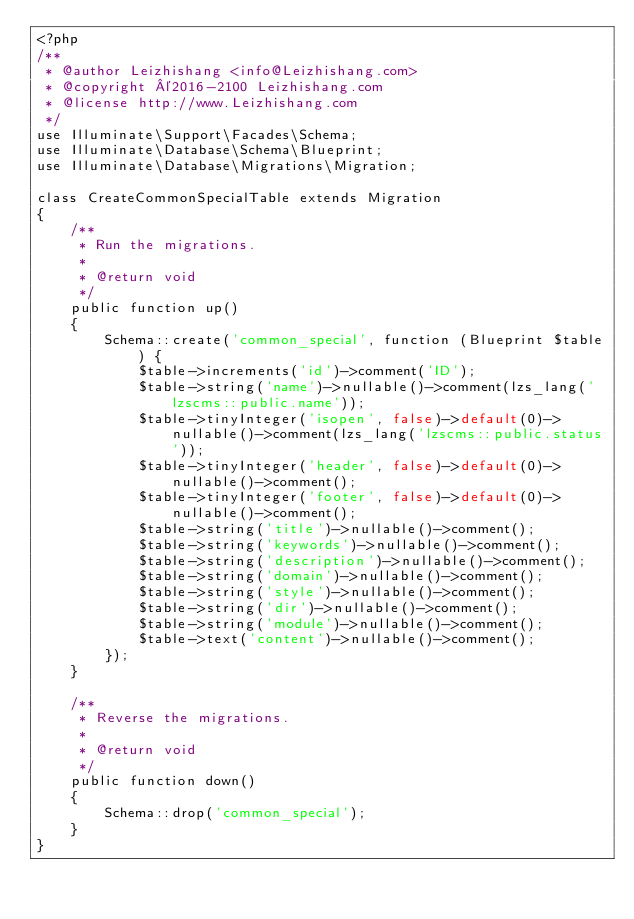<code> <loc_0><loc_0><loc_500><loc_500><_PHP_><?php
/**
 * @author Leizhishang <info@Leizhishang.com>
 * @copyright ©2016-2100 Leizhishang.com
 * @license http://www.Leizhishang.com
 */
use Illuminate\Support\Facades\Schema;
use Illuminate\Database\Schema\Blueprint;
use Illuminate\Database\Migrations\Migration;

class CreateCommonSpecialTable extends Migration
{
    /**
     * Run the migrations.
     *
     * @return void
     */
    public function up()
    {
        Schema::create('common_special', function (Blueprint $table) {
            $table->increments('id')->comment('ID');
            $table->string('name')->nullable()->comment(lzs_lang('lzscms::public.name'));
            $table->tinyInteger('isopen', false)->default(0)->nullable()->comment(lzs_lang('lzscms::public.status'));
            $table->tinyInteger('header', false)->default(0)->nullable()->comment();
            $table->tinyInteger('footer', false)->default(0)->nullable()->comment();
            $table->string('title')->nullable()->comment();
            $table->string('keywords')->nullable()->comment();
            $table->string('description')->nullable()->comment();
            $table->string('domain')->nullable()->comment();
            $table->string('style')->nullable()->comment();
            $table->string('dir')->nullable()->comment();
            $table->string('module')->nullable()->comment();
            $table->text('content')->nullable()->comment();
        });
    }

    /**
     * Reverse the migrations.
     *
     * @return void
     */
    public function down()
    {
        Schema::drop('common_special');
    }
}
</code> 